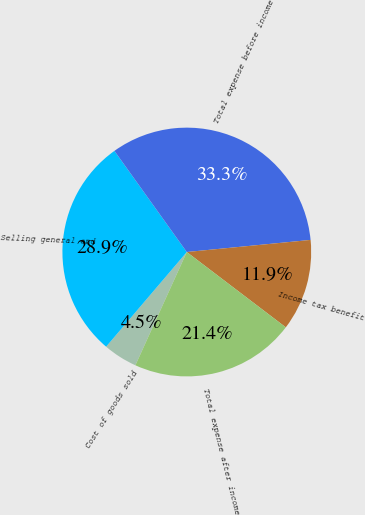Convert chart to OTSL. <chart><loc_0><loc_0><loc_500><loc_500><pie_chart><fcel>Cost of goods sold<fcel>Selling general and<fcel>Total expense before income<fcel>Income tax benefit<fcel>Total expense after income<nl><fcel>4.45%<fcel>28.88%<fcel>33.33%<fcel>11.9%<fcel>21.43%<nl></chart> 